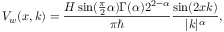Convert formula to latex. <formula><loc_0><loc_0><loc_500><loc_500>V _ { w } ( x , k ) = \frac { H \sin ( \frac { \pi } { 2 } \alpha ) \Gamma ( \alpha ) 2 ^ { 2 - \alpha } } { \pi } \frac { \sin ( 2 x k ) } { | k | ^ { \alpha } } ,</formula> 